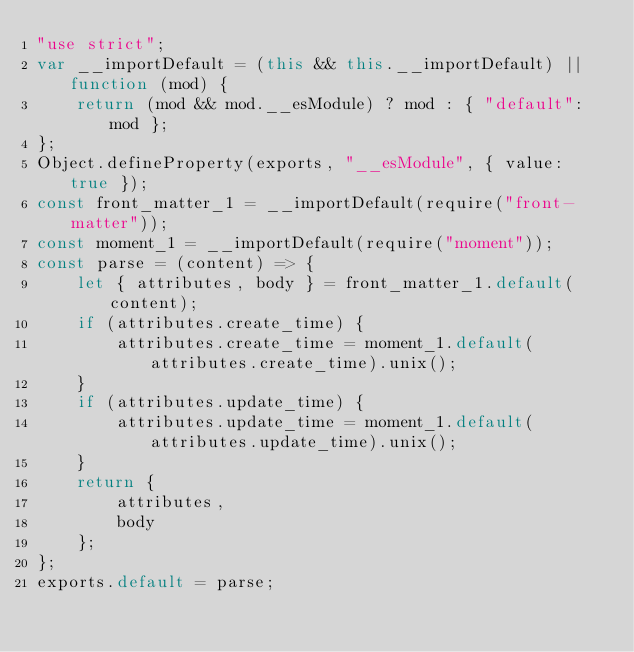<code> <loc_0><loc_0><loc_500><loc_500><_JavaScript_>"use strict";
var __importDefault = (this && this.__importDefault) || function (mod) {
    return (mod && mod.__esModule) ? mod : { "default": mod };
};
Object.defineProperty(exports, "__esModule", { value: true });
const front_matter_1 = __importDefault(require("front-matter"));
const moment_1 = __importDefault(require("moment"));
const parse = (content) => {
    let { attributes, body } = front_matter_1.default(content);
    if (attributes.create_time) {
        attributes.create_time = moment_1.default(attributes.create_time).unix();
    }
    if (attributes.update_time) {
        attributes.update_time = moment_1.default(attributes.update_time).unix();
    }
    return {
        attributes,
        body
    };
};
exports.default = parse;
</code> 